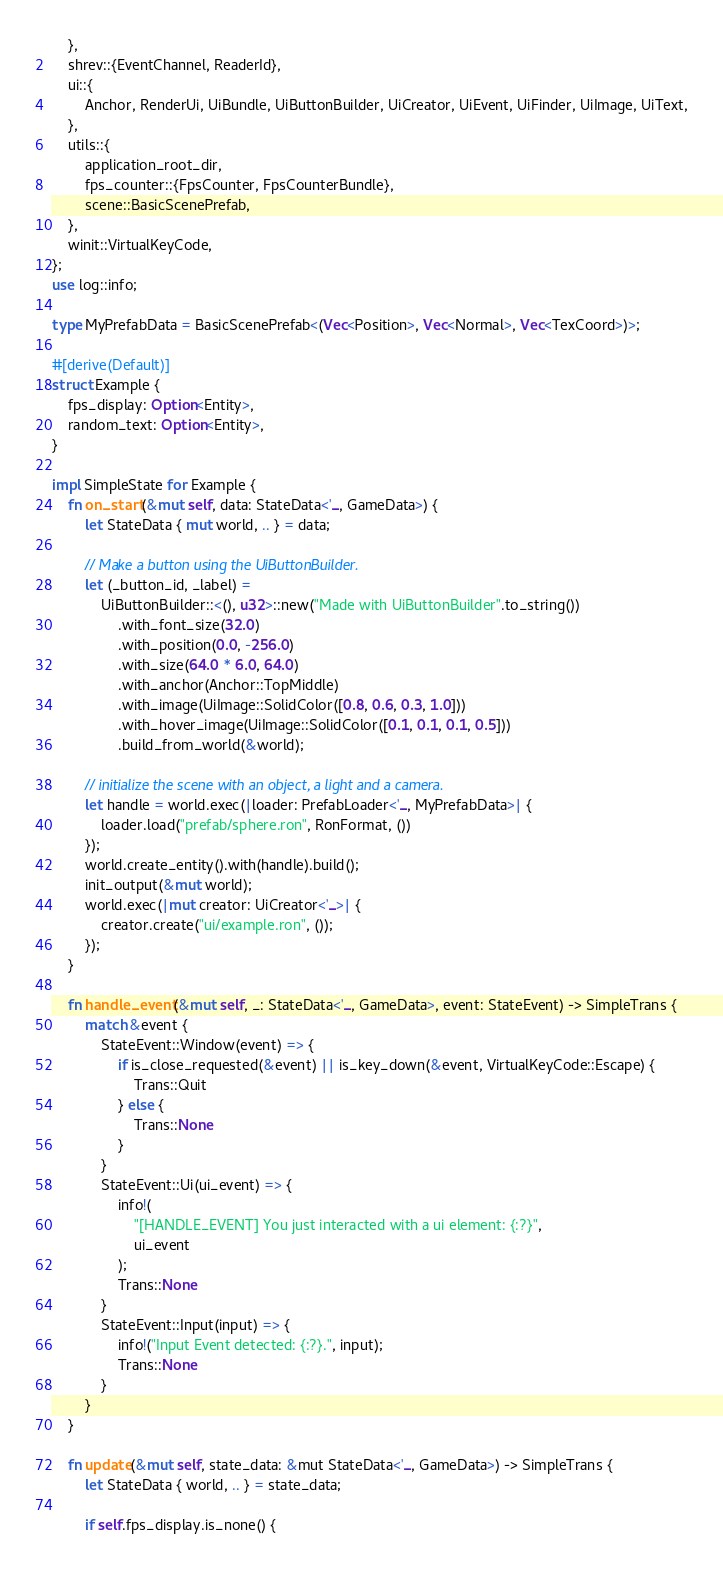Convert code to text. <code><loc_0><loc_0><loc_500><loc_500><_Rust_>    },
    shrev::{EventChannel, ReaderId},
    ui::{
        Anchor, RenderUi, UiBundle, UiButtonBuilder, UiCreator, UiEvent, UiFinder, UiImage, UiText,
    },
    utils::{
        application_root_dir,
        fps_counter::{FpsCounter, FpsCounterBundle},
        scene::BasicScenePrefab,
    },
    winit::VirtualKeyCode,
};
use log::info;

type MyPrefabData = BasicScenePrefab<(Vec<Position>, Vec<Normal>, Vec<TexCoord>)>;

#[derive(Default)]
struct Example {
    fps_display: Option<Entity>,
    random_text: Option<Entity>,
}

impl SimpleState for Example {
    fn on_start(&mut self, data: StateData<'_, GameData>) {
        let StateData { mut world, .. } = data;

        // Make a button using the UiButtonBuilder.
        let (_button_id, _label) =
            UiButtonBuilder::<(), u32>::new("Made with UiButtonBuilder".to_string())
                .with_font_size(32.0)
                .with_position(0.0, -256.0)
                .with_size(64.0 * 6.0, 64.0)
                .with_anchor(Anchor::TopMiddle)
                .with_image(UiImage::SolidColor([0.8, 0.6, 0.3, 1.0]))
                .with_hover_image(UiImage::SolidColor([0.1, 0.1, 0.1, 0.5]))
                .build_from_world(&world);

        // initialize the scene with an object, a light and a camera.
        let handle = world.exec(|loader: PrefabLoader<'_, MyPrefabData>| {
            loader.load("prefab/sphere.ron", RonFormat, ())
        });
        world.create_entity().with(handle).build();
        init_output(&mut world);
        world.exec(|mut creator: UiCreator<'_>| {
            creator.create("ui/example.ron", ());
        });
    }

    fn handle_event(&mut self, _: StateData<'_, GameData>, event: StateEvent) -> SimpleTrans {
        match &event {
            StateEvent::Window(event) => {
                if is_close_requested(&event) || is_key_down(&event, VirtualKeyCode::Escape) {
                    Trans::Quit
                } else {
                    Trans::None
                }
            }
            StateEvent::Ui(ui_event) => {
                info!(
                    "[HANDLE_EVENT] You just interacted with a ui element: {:?}",
                    ui_event
                );
                Trans::None
            }
            StateEvent::Input(input) => {
                info!("Input Event detected: {:?}.", input);
                Trans::None
            }
        }
    }

    fn update(&mut self, state_data: &mut StateData<'_, GameData>) -> SimpleTrans {
        let StateData { world, .. } = state_data;

        if self.fps_display.is_none() {</code> 